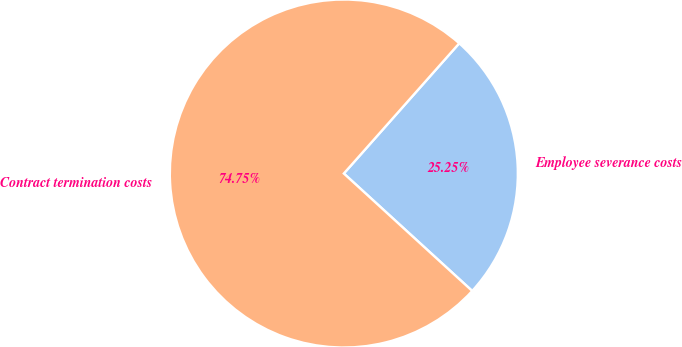Convert chart. <chart><loc_0><loc_0><loc_500><loc_500><pie_chart><fcel>Employee severance costs<fcel>Contract termination costs<nl><fcel>25.25%<fcel>74.75%<nl></chart> 